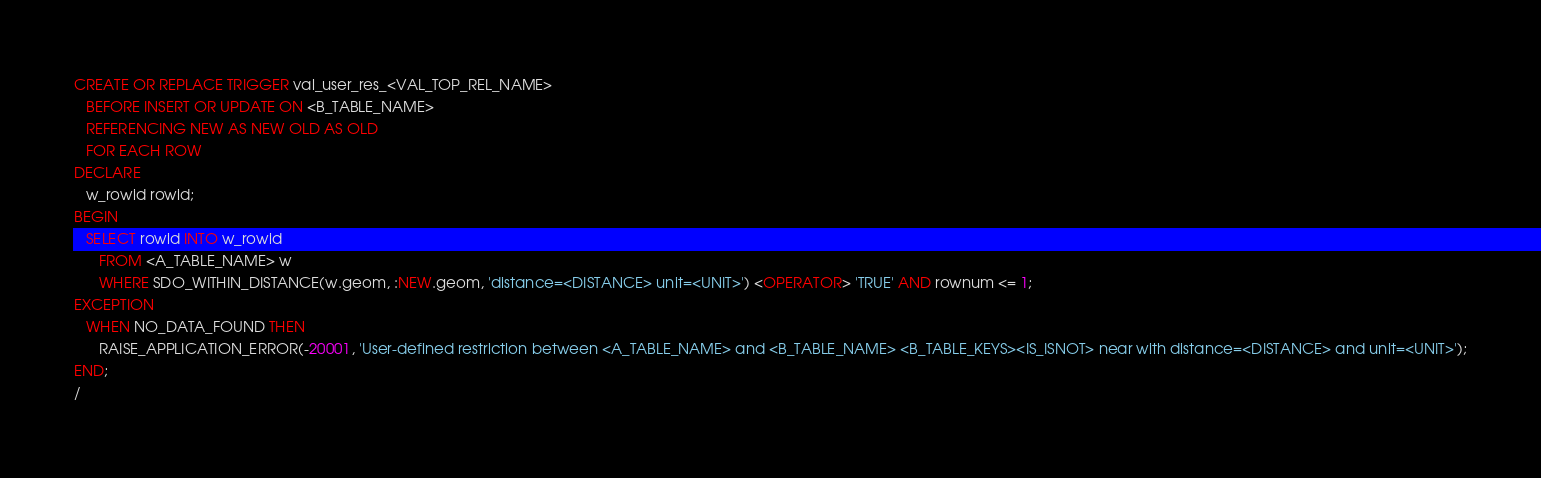<code> <loc_0><loc_0><loc_500><loc_500><_SQL_>CREATE OR REPLACE TRIGGER val_user_res_<VAL_TOP_REL_NAME>
   BEFORE INSERT OR UPDATE ON <B_TABLE_NAME>
   REFERENCING NEW AS NEW OLD AS OLD
   FOR EACH ROW
DECLARE
   w_rowid rowid;
BEGIN
   SELECT rowid INTO w_rowid
      FROM <A_TABLE_NAME> w
      WHERE SDO_WITHIN_DISTANCE(w.geom, :NEW.geom, 'distance=<DISTANCE> unit=<UNIT>') <OPERATOR> 'TRUE' AND rownum <= 1;
EXCEPTION
   WHEN NO_DATA_FOUND THEN
      RAISE_APPLICATION_ERROR(-20001, 'User-defined restriction between <A_TABLE_NAME> and <B_TABLE_NAME> <B_TABLE_KEYS><IS_ISNOT> near with distance=<DISTANCE> and unit=<UNIT>');
END;
/</code> 